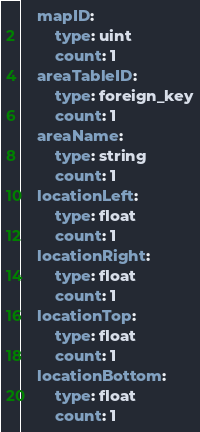Convert code to text. <code><loc_0><loc_0><loc_500><loc_500><_YAML_>    mapID:
        type: uint
        count: 1
    areaTableID:
        type: foreign_key
        count: 1
    areaName:
        type: string
        count: 1
    locationLeft:
        type: float
        count: 1
    locationRight:
        type: float
        count: 1
    locationTop:
        type: float
        count: 1
    locationBottom:
        type: float
        count: 1
</code> 